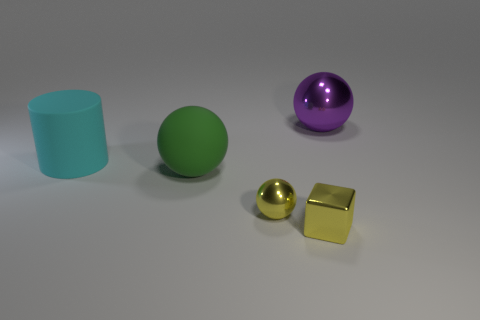Add 1 small gray balls. How many objects exist? 6 Subtract all cylinders. How many objects are left? 4 Subtract all purple spheres. Subtract all green metallic blocks. How many objects are left? 4 Add 4 yellow things. How many yellow things are left? 6 Add 5 small gray metallic things. How many small gray metallic things exist? 5 Subtract 0 cyan blocks. How many objects are left? 5 